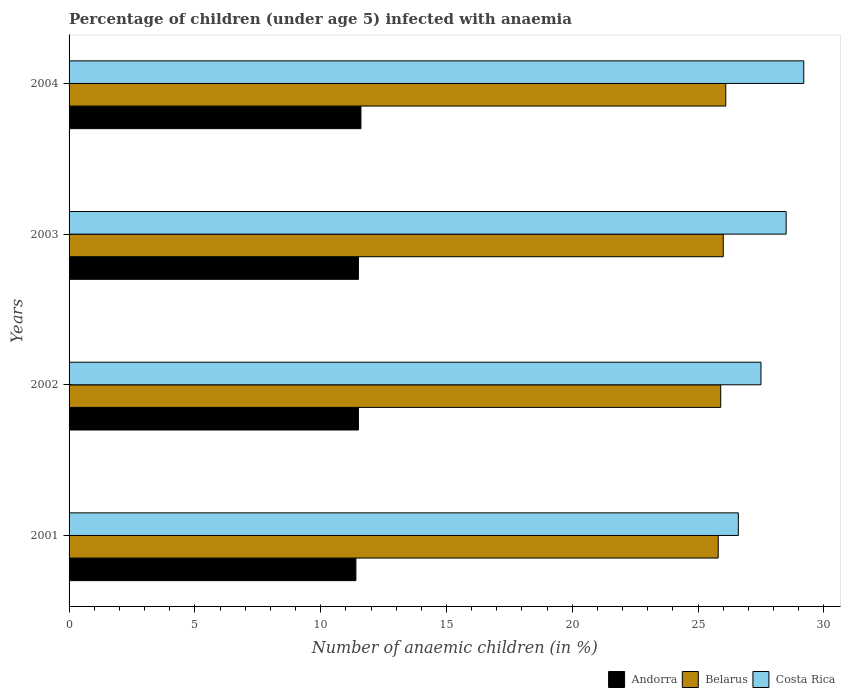How many different coloured bars are there?
Offer a very short reply. 3. Are the number of bars per tick equal to the number of legend labels?
Keep it short and to the point. Yes. How many bars are there on the 4th tick from the bottom?
Give a very brief answer. 3. What is the label of the 2nd group of bars from the top?
Your answer should be compact. 2003. What is the percentage of children infected with anaemia in in Belarus in 2002?
Ensure brevity in your answer.  25.9. Across all years, what is the maximum percentage of children infected with anaemia in in Andorra?
Give a very brief answer. 11.6. Across all years, what is the minimum percentage of children infected with anaemia in in Belarus?
Offer a terse response. 25.8. In which year was the percentage of children infected with anaemia in in Andorra minimum?
Make the answer very short. 2001. What is the total percentage of children infected with anaemia in in Belarus in the graph?
Keep it short and to the point. 103.8. What is the difference between the percentage of children infected with anaemia in in Andorra in 2001 and that in 2004?
Ensure brevity in your answer.  -0.2. What is the difference between the percentage of children infected with anaemia in in Belarus in 2004 and the percentage of children infected with anaemia in in Andorra in 2003?
Make the answer very short. 14.6. What is the average percentage of children infected with anaemia in in Costa Rica per year?
Your response must be concise. 27.95. In the year 2002, what is the difference between the percentage of children infected with anaemia in in Andorra and percentage of children infected with anaemia in in Costa Rica?
Your answer should be compact. -16. In how many years, is the percentage of children infected with anaemia in in Belarus greater than 4 %?
Your answer should be very brief. 4. What is the ratio of the percentage of children infected with anaemia in in Belarus in 2001 to that in 2002?
Your answer should be very brief. 1. What is the difference between the highest and the second highest percentage of children infected with anaemia in in Costa Rica?
Offer a terse response. 0.7. What is the difference between the highest and the lowest percentage of children infected with anaemia in in Costa Rica?
Offer a very short reply. 2.6. In how many years, is the percentage of children infected with anaemia in in Costa Rica greater than the average percentage of children infected with anaemia in in Costa Rica taken over all years?
Keep it short and to the point. 2. What does the 3rd bar from the top in 2004 represents?
Keep it short and to the point. Andorra. Is it the case that in every year, the sum of the percentage of children infected with anaemia in in Andorra and percentage of children infected with anaemia in in Belarus is greater than the percentage of children infected with anaemia in in Costa Rica?
Offer a very short reply. Yes. How many bars are there?
Offer a terse response. 12. Are all the bars in the graph horizontal?
Provide a short and direct response. Yes. Are the values on the major ticks of X-axis written in scientific E-notation?
Offer a very short reply. No. What is the title of the graph?
Your answer should be compact. Percentage of children (under age 5) infected with anaemia. What is the label or title of the X-axis?
Keep it short and to the point. Number of anaemic children (in %). What is the Number of anaemic children (in %) in Andorra in 2001?
Offer a terse response. 11.4. What is the Number of anaemic children (in %) in Belarus in 2001?
Ensure brevity in your answer.  25.8. What is the Number of anaemic children (in %) in Costa Rica in 2001?
Your response must be concise. 26.6. What is the Number of anaemic children (in %) in Andorra in 2002?
Your answer should be compact. 11.5. What is the Number of anaemic children (in %) of Belarus in 2002?
Keep it short and to the point. 25.9. What is the Number of anaemic children (in %) in Costa Rica in 2002?
Offer a terse response. 27.5. What is the Number of anaemic children (in %) in Andorra in 2003?
Offer a terse response. 11.5. What is the Number of anaemic children (in %) of Costa Rica in 2003?
Ensure brevity in your answer.  28.5. What is the Number of anaemic children (in %) of Andorra in 2004?
Give a very brief answer. 11.6. What is the Number of anaemic children (in %) of Belarus in 2004?
Keep it short and to the point. 26.1. What is the Number of anaemic children (in %) of Costa Rica in 2004?
Make the answer very short. 29.2. Across all years, what is the maximum Number of anaemic children (in %) of Belarus?
Give a very brief answer. 26.1. Across all years, what is the maximum Number of anaemic children (in %) of Costa Rica?
Offer a very short reply. 29.2. Across all years, what is the minimum Number of anaemic children (in %) in Belarus?
Make the answer very short. 25.8. Across all years, what is the minimum Number of anaemic children (in %) of Costa Rica?
Provide a short and direct response. 26.6. What is the total Number of anaemic children (in %) of Andorra in the graph?
Offer a terse response. 46. What is the total Number of anaemic children (in %) of Belarus in the graph?
Keep it short and to the point. 103.8. What is the total Number of anaemic children (in %) of Costa Rica in the graph?
Keep it short and to the point. 111.8. What is the difference between the Number of anaemic children (in %) in Belarus in 2001 and that in 2002?
Your response must be concise. -0.1. What is the difference between the Number of anaemic children (in %) in Costa Rica in 2001 and that in 2002?
Your answer should be compact. -0.9. What is the difference between the Number of anaemic children (in %) in Belarus in 2001 and that in 2003?
Your answer should be compact. -0.2. What is the difference between the Number of anaemic children (in %) of Belarus in 2001 and that in 2004?
Ensure brevity in your answer.  -0.3. What is the difference between the Number of anaemic children (in %) in Costa Rica in 2001 and that in 2004?
Your answer should be very brief. -2.6. What is the difference between the Number of anaemic children (in %) of Belarus in 2002 and that in 2003?
Your answer should be compact. -0.1. What is the difference between the Number of anaemic children (in %) of Andorra in 2002 and that in 2004?
Ensure brevity in your answer.  -0.1. What is the difference between the Number of anaemic children (in %) of Andorra in 2003 and that in 2004?
Keep it short and to the point. -0.1. What is the difference between the Number of anaemic children (in %) in Costa Rica in 2003 and that in 2004?
Provide a succinct answer. -0.7. What is the difference between the Number of anaemic children (in %) in Andorra in 2001 and the Number of anaemic children (in %) in Belarus in 2002?
Offer a terse response. -14.5. What is the difference between the Number of anaemic children (in %) in Andorra in 2001 and the Number of anaemic children (in %) in Costa Rica in 2002?
Your answer should be very brief. -16.1. What is the difference between the Number of anaemic children (in %) in Andorra in 2001 and the Number of anaemic children (in %) in Belarus in 2003?
Offer a very short reply. -14.6. What is the difference between the Number of anaemic children (in %) of Andorra in 2001 and the Number of anaemic children (in %) of Costa Rica in 2003?
Keep it short and to the point. -17.1. What is the difference between the Number of anaemic children (in %) of Belarus in 2001 and the Number of anaemic children (in %) of Costa Rica in 2003?
Your answer should be very brief. -2.7. What is the difference between the Number of anaemic children (in %) of Andorra in 2001 and the Number of anaemic children (in %) of Belarus in 2004?
Provide a succinct answer. -14.7. What is the difference between the Number of anaemic children (in %) in Andorra in 2001 and the Number of anaemic children (in %) in Costa Rica in 2004?
Provide a short and direct response. -17.8. What is the difference between the Number of anaemic children (in %) of Andorra in 2002 and the Number of anaemic children (in %) of Belarus in 2003?
Your answer should be very brief. -14.5. What is the difference between the Number of anaemic children (in %) of Andorra in 2002 and the Number of anaemic children (in %) of Costa Rica in 2003?
Keep it short and to the point. -17. What is the difference between the Number of anaemic children (in %) in Andorra in 2002 and the Number of anaemic children (in %) in Belarus in 2004?
Give a very brief answer. -14.6. What is the difference between the Number of anaemic children (in %) of Andorra in 2002 and the Number of anaemic children (in %) of Costa Rica in 2004?
Make the answer very short. -17.7. What is the difference between the Number of anaemic children (in %) in Belarus in 2002 and the Number of anaemic children (in %) in Costa Rica in 2004?
Offer a terse response. -3.3. What is the difference between the Number of anaemic children (in %) of Andorra in 2003 and the Number of anaemic children (in %) of Belarus in 2004?
Your response must be concise. -14.6. What is the difference between the Number of anaemic children (in %) of Andorra in 2003 and the Number of anaemic children (in %) of Costa Rica in 2004?
Give a very brief answer. -17.7. What is the difference between the Number of anaemic children (in %) of Belarus in 2003 and the Number of anaemic children (in %) of Costa Rica in 2004?
Give a very brief answer. -3.2. What is the average Number of anaemic children (in %) in Belarus per year?
Keep it short and to the point. 25.95. What is the average Number of anaemic children (in %) in Costa Rica per year?
Your answer should be compact. 27.95. In the year 2001, what is the difference between the Number of anaemic children (in %) of Andorra and Number of anaemic children (in %) of Belarus?
Give a very brief answer. -14.4. In the year 2001, what is the difference between the Number of anaemic children (in %) of Andorra and Number of anaemic children (in %) of Costa Rica?
Give a very brief answer. -15.2. In the year 2001, what is the difference between the Number of anaemic children (in %) of Belarus and Number of anaemic children (in %) of Costa Rica?
Your answer should be compact. -0.8. In the year 2002, what is the difference between the Number of anaemic children (in %) in Andorra and Number of anaemic children (in %) in Belarus?
Make the answer very short. -14.4. In the year 2002, what is the difference between the Number of anaemic children (in %) of Andorra and Number of anaemic children (in %) of Costa Rica?
Your answer should be very brief. -16. In the year 2002, what is the difference between the Number of anaemic children (in %) of Belarus and Number of anaemic children (in %) of Costa Rica?
Offer a very short reply. -1.6. In the year 2003, what is the difference between the Number of anaemic children (in %) in Belarus and Number of anaemic children (in %) in Costa Rica?
Ensure brevity in your answer.  -2.5. In the year 2004, what is the difference between the Number of anaemic children (in %) of Andorra and Number of anaemic children (in %) of Costa Rica?
Your answer should be very brief. -17.6. What is the ratio of the Number of anaemic children (in %) in Andorra in 2001 to that in 2002?
Offer a very short reply. 0.99. What is the ratio of the Number of anaemic children (in %) of Costa Rica in 2001 to that in 2002?
Your answer should be compact. 0.97. What is the ratio of the Number of anaemic children (in %) of Andorra in 2001 to that in 2004?
Keep it short and to the point. 0.98. What is the ratio of the Number of anaemic children (in %) of Costa Rica in 2001 to that in 2004?
Your answer should be compact. 0.91. What is the ratio of the Number of anaemic children (in %) in Andorra in 2002 to that in 2003?
Your answer should be very brief. 1. What is the ratio of the Number of anaemic children (in %) of Costa Rica in 2002 to that in 2003?
Your answer should be compact. 0.96. What is the ratio of the Number of anaemic children (in %) in Andorra in 2002 to that in 2004?
Your response must be concise. 0.99. What is the ratio of the Number of anaemic children (in %) of Belarus in 2002 to that in 2004?
Give a very brief answer. 0.99. What is the ratio of the Number of anaemic children (in %) in Costa Rica in 2002 to that in 2004?
Provide a short and direct response. 0.94. What is the ratio of the Number of anaemic children (in %) of Belarus in 2003 to that in 2004?
Offer a very short reply. 1. What is the ratio of the Number of anaemic children (in %) of Costa Rica in 2003 to that in 2004?
Provide a succinct answer. 0.98. What is the difference between the highest and the second highest Number of anaemic children (in %) in Belarus?
Your response must be concise. 0.1. What is the difference between the highest and the second highest Number of anaemic children (in %) in Costa Rica?
Your answer should be compact. 0.7. 